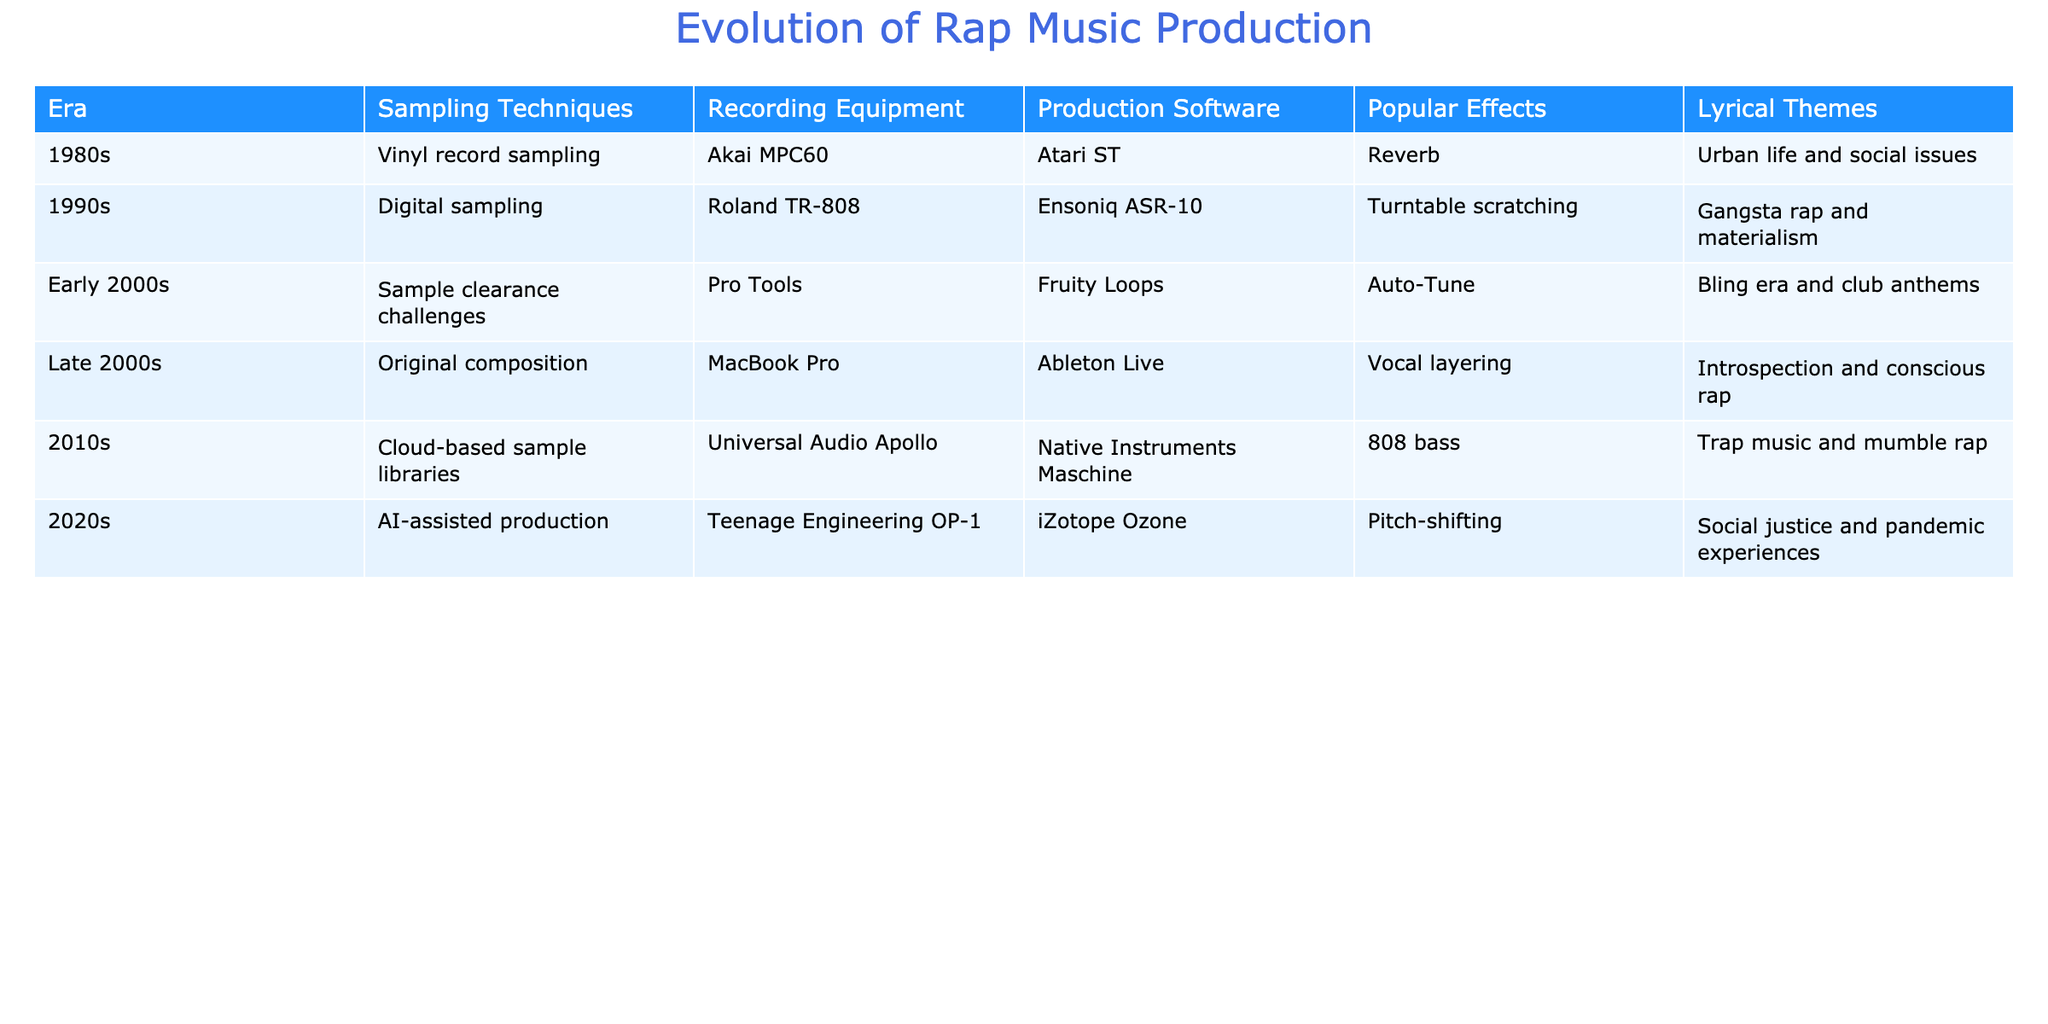What sampling technique was used in the 1990s? According to the table, the sampling technique listed for the 1990s is digital sampling.
Answer: Digital sampling What recording equipment was popular in the 1980s? The table mentions the Akai MPC60 as the recording equipment popular in the 1980s.
Answer: Akai MPC60 Which production software was used in the early 2000s? The early 2000s saw the use of Pro Tools as the production software, according to the table.
Answer: Pro Tools What was a common lyrical theme in the late 2000s? The table indicates that the lyrical theme in the late 2000s was introspection and conscious rap.
Answer: Introspection and conscious rap How many eras included the use of Auto-Tune as a popular effect? From the table, Auto-Tune appears in one era, which is the early 2000s.
Answer: 1 What was the main lyrical theme of the 2010s? The table shows that the primary lyrical theme of the 2010s revolved around trap music and mumble rap.
Answer: Trap music and mumble rap In which era did original composition become the dominant production technique? According to the table, original composition became the dominant technique in the late 2000s.
Answer: Late 2000s How many eras utilized cloud-based sample libraries in production? The table indicates that cloud-based sample libraries were utilized in the 2010s. Therefore, that makes it 1 era.
Answer: 1 Which effect was commonly used in the 2020s? The table states that pitch-shifting was a commonly used effect in the 2020s.
Answer: Pitch-shifting What is the difference in popular effects between the 1990s and 2010s? In the 1990s, turntable scratching was the popular effect, while in the 2010s it was 808 bass. Thus, the difference is between turntable scratching and 808 bass.
Answer: Turntable scratching and 808 bass What production software transitioned from the early 2000s to the late 2000s? The production software transitioned from Fruity Loops in the early 2000s to Ableton Live in the late 2000s, which can be seen in the table.
Answer: Fruity Loops to Ableton Live Which era introduced AI-assisted production and what was a popular effect during that time? The table shows that AI-assisted production was introduced in the 2020s, and the popular effect during that time was pitch-shifting. Thus, the answer comprises both facts.
Answer: 2020s; pitch-shifting What can be inferred about the relationship between lyrical themes and production techniques over the decades? Analyzing the table, there seems to be a correlation between lyrical themes evolving towards introspective and socially conscious themes while production techniques transition from sampling to original compositions and AI-assisted production. This shows a shift in focus and depth in rap music over the decades.
Answer: Evolving lyrical themes correspond to changes in production techniques 